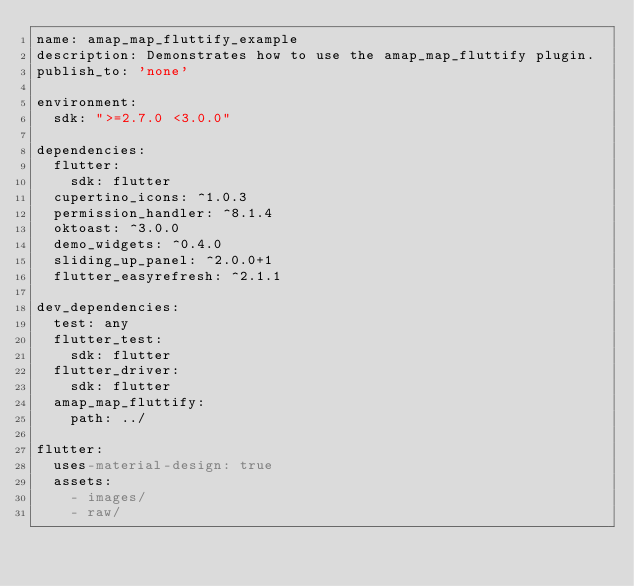Convert code to text. <code><loc_0><loc_0><loc_500><loc_500><_YAML_>name: amap_map_fluttify_example
description: Demonstrates how to use the amap_map_fluttify plugin.
publish_to: 'none'

environment:
  sdk: ">=2.7.0 <3.0.0"

dependencies:
  flutter:
    sdk: flutter
  cupertino_icons: ^1.0.3
  permission_handler: ^8.1.4
  oktoast: ^3.0.0
  demo_widgets: ^0.4.0
  sliding_up_panel: ^2.0.0+1
  flutter_easyrefresh: ^2.1.1

dev_dependencies:
  test: any
  flutter_test:
    sdk: flutter
  flutter_driver:
    sdk: flutter
  amap_map_fluttify:
    path: ../

flutter:
  uses-material-design: true
  assets:
    - images/
    - raw/</code> 